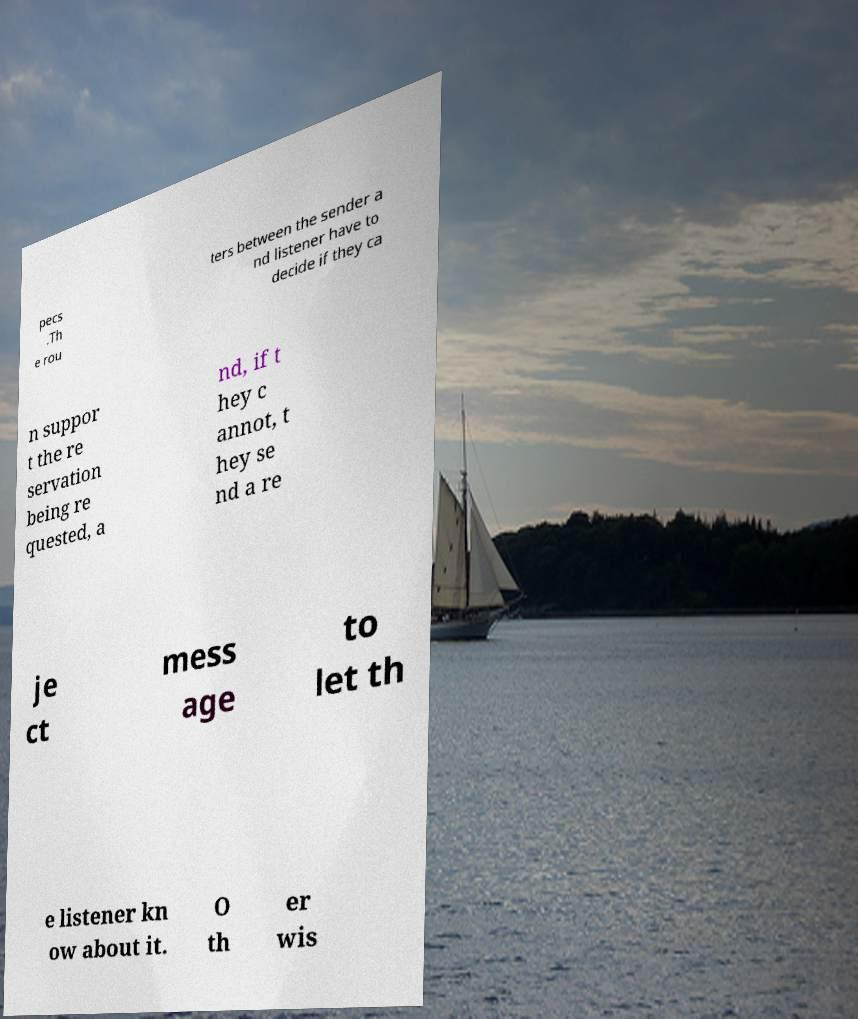Could you extract and type out the text from this image? pecs .Th e rou ters between the sender a nd listener have to decide if they ca n suppor t the re servation being re quested, a nd, if t hey c annot, t hey se nd a re je ct mess age to let th e listener kn ow about it. O th er wis 